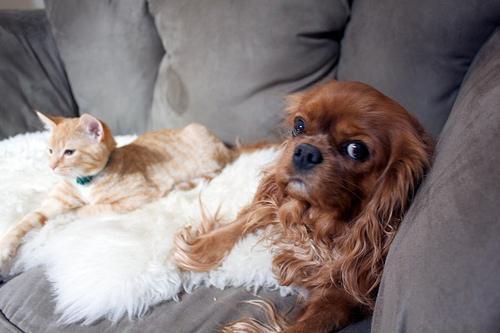How many animals are here?
Give a very brief answer. 2. How many dogs can be seen?
Give a very brief answer. 1. How many people are on the elephant on the right?
Give a very brief answer. 0. 